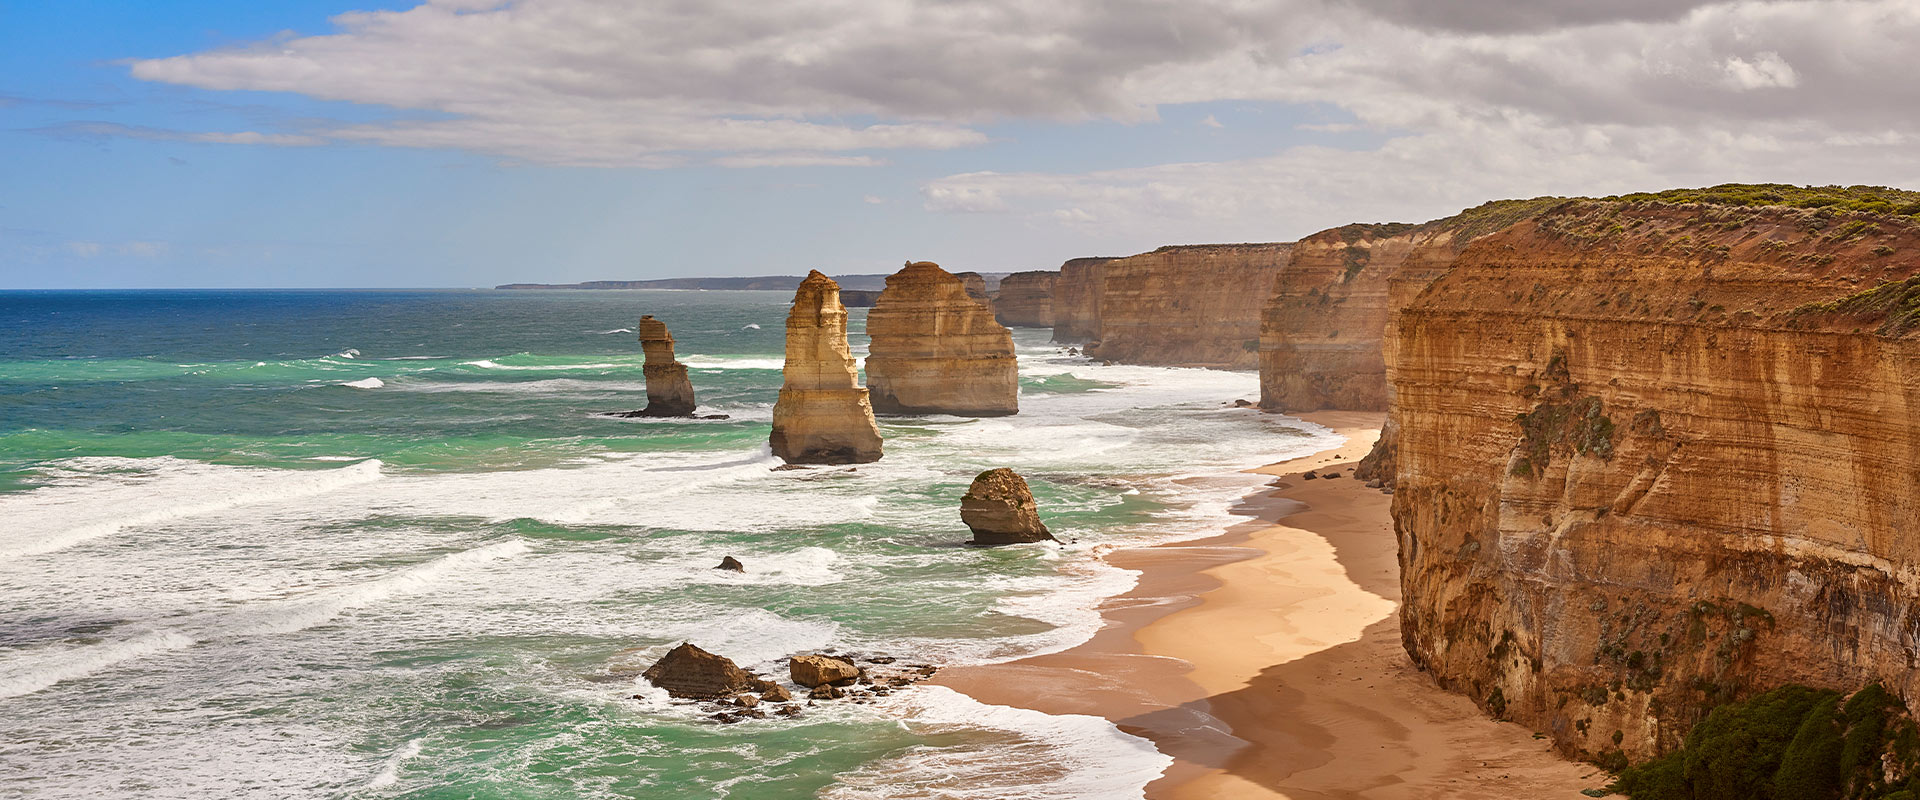How does this site contribute to the local ecosystem? The Twelve Apostles area, part of the Port Campbell National Park, plays a crucial role in the local ecosystem. It provides habitat for various marine species near its bases and serves as an important breeding ground for seabirds. The vegetation upon the cliffs and surrounding areas also supports diverse wildlife, including native birds and small mammals, forming a complex ecosystem that contributes to biodiversity conservation in the region. Are there conservation efforts in place to protect this area? Yes, there are active conservation efforts managed by Parks Victoria. These include monitoring of the ecological health of the area, protecting wildlife habitats from human interference, and maintaining the integrity of both marine and coastal environments. Educational programs are also implemented to raise awareness among visitors about the importance of preserving such unique natural sites. 